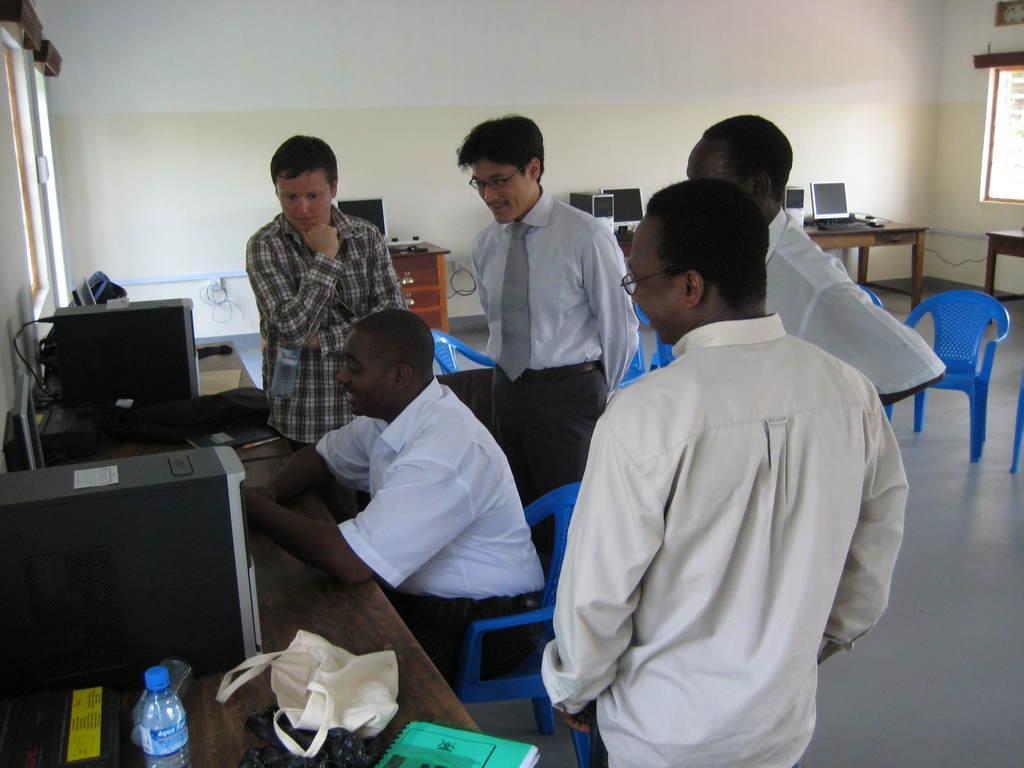Please provide a concise description of this image. In this picture we can see five men where four are standing and looking at person sitting on chair and in front of them there is table and on table we can see book, bag, bottle, CPU, monitor and in background we can see wall, window, chairs. 